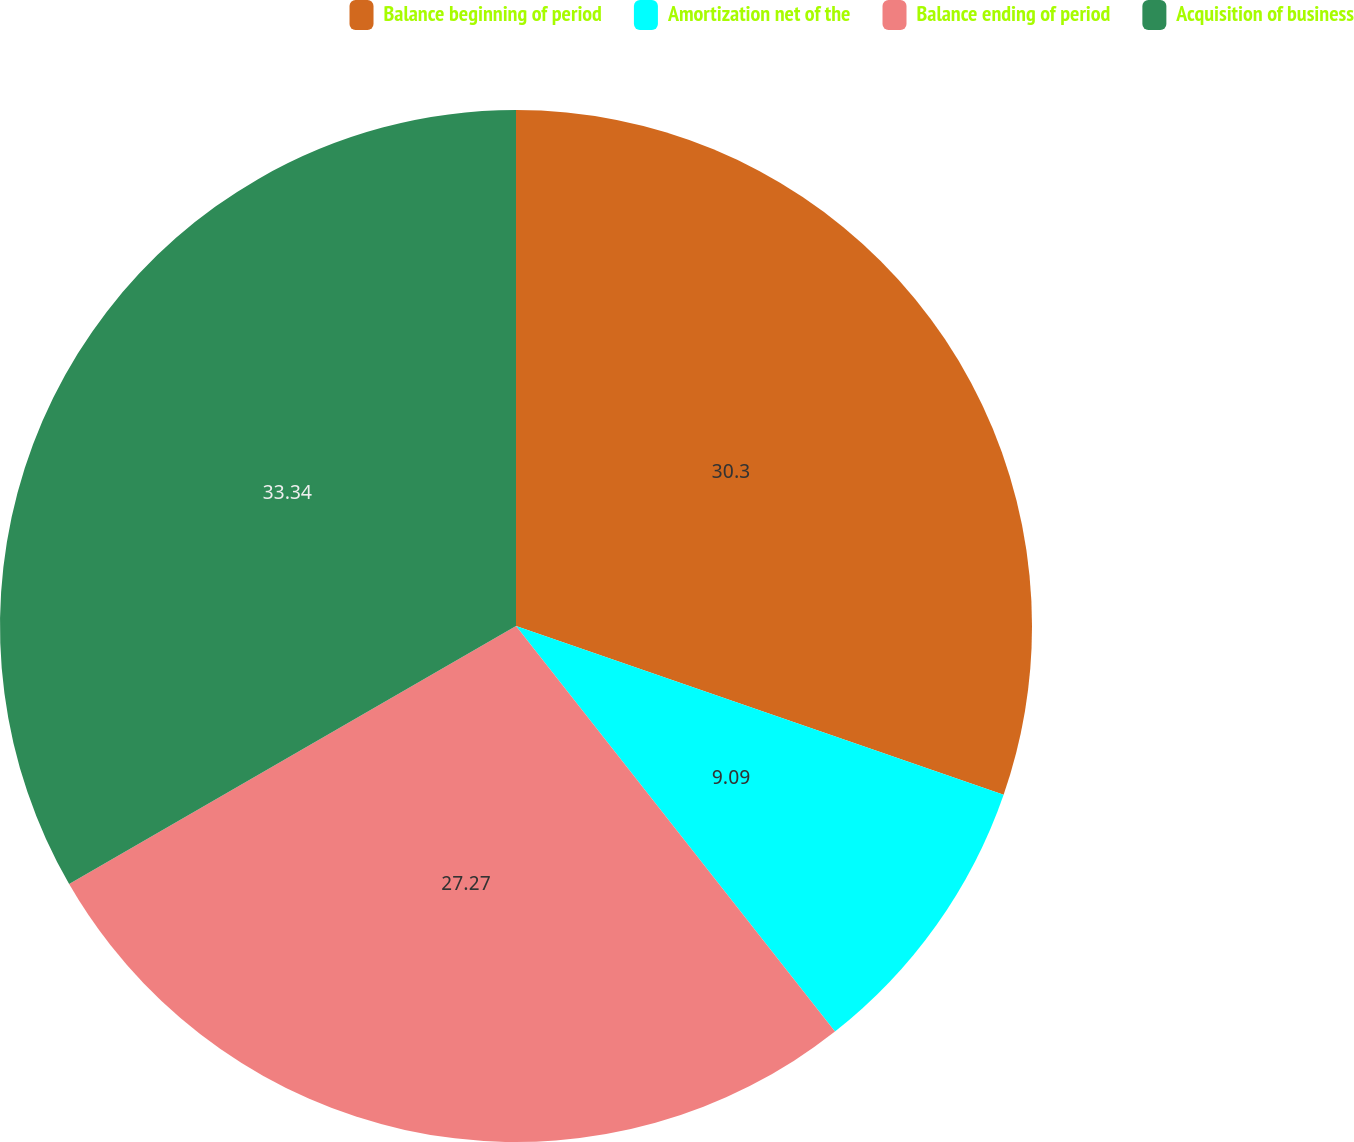Convert chart. <chart><loc_0><loc_0><loc_500><loc_500><pie_chart><fcel>Balance beginning of period<fcel>Amortization net of the<fcel>Balance ending of period<fcel>Acquisition of business<nl><fcel>30.3%<fcel>9.09%<fcel>27.27%<fcel>33.33%<nl></chart> 